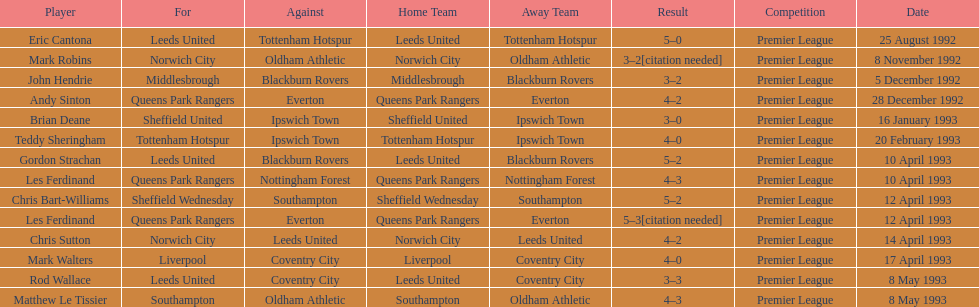Name the only player from france. Eric Cantona. Parse the table in full. {'header': ['Player', 'For', 'Against', 'Home Team', 'Away Team', 'Result', 'Competition', 'Date'], 'rows': [['Eric Cantona', 'Leeds United', 'Tottenham Hotspur', 'Leeds United', 'Tottenham Hotspur', '5–0', 'Premier League', '25 August 1992'], ['Mark Robins', 'Norwich City', 'Oldham Athletic', 'Norwich City', 'Oldham Athletic', '3–2[citation needed]', 'Premier League', '8 November 1992'], ['John Hendrie', 'Middlesbrough', 'Blackburn Rovers', 'Middlesbrough', 'Blackburn Rovers', '3–2', 'Premier League', '5 December 1992'], ['Andy Sinton', 'Queens Park Rangers', 'Everton', 'Queens Park Rangers', 'Everton', '4–2', 'Premier League', '28 December 1992'], ['Brian Deane', 'Sheffield United', 'Ipswich Town', 'Sheffield United', 'Ipswich Town', '3–0', 'Premier League', '16 January 1993'], ['Teddy Sheringham', 'Tottenham Hotspur', 'Ipswich Town', 'Tottenham Hotspur', 'Ipswich Town', '4–0', 'Premier League', '20 February 1993'], ['Gordon Strachan', 'Leeds United', 'Blackburn Rovers', 'Leeds United', 'Blackburn Rovers', '5–2', 'Premier League', '10 April 1993'], ['Les Ferdinand', 'Queens Park Rangers', 'Nottingham Forest', 'Queens Park Rangers', 'Nottingham Forest', '4–3', 'Premier League', '10 April 1993'], ['Chris Bart-Williams', 'Sheffield Wednesday', 'Southampton', 'Sheffield Wednesday', 'Southampton', '5–2', 'Premier League', '12 April 1993'], ['Les Ferdinand', 'Queens Park Rangers', 'Everton', 'Queens Park Rangers', 'Everton', '5–3[citation needed]', 'Premier League', '12 April 1993'], ['Chris Sutton', 'Norwich City', 'Leeds United', 'Norwich City', 'Leeds United', '4–2', 'Premier League', '14 April 1993'], ['Mark Walters', 'Liverpool', 'Coventry City', 'Liverpool', 'Coventry City', '4–0', 'Premier League', '17 April 1993'], ['Rod Wallace', 'Leeds United', 'Coventry City', 'Leeds United', 'Coventry City', '3–3', 'Premier League', '8 May 1993'], ['Matthew Le Tissier', 'Southampton', 'Oldham Athletic', 'Southampton', 'Oldham Athletic', '4–3', 'Premier League', '8 May 1993']]} 